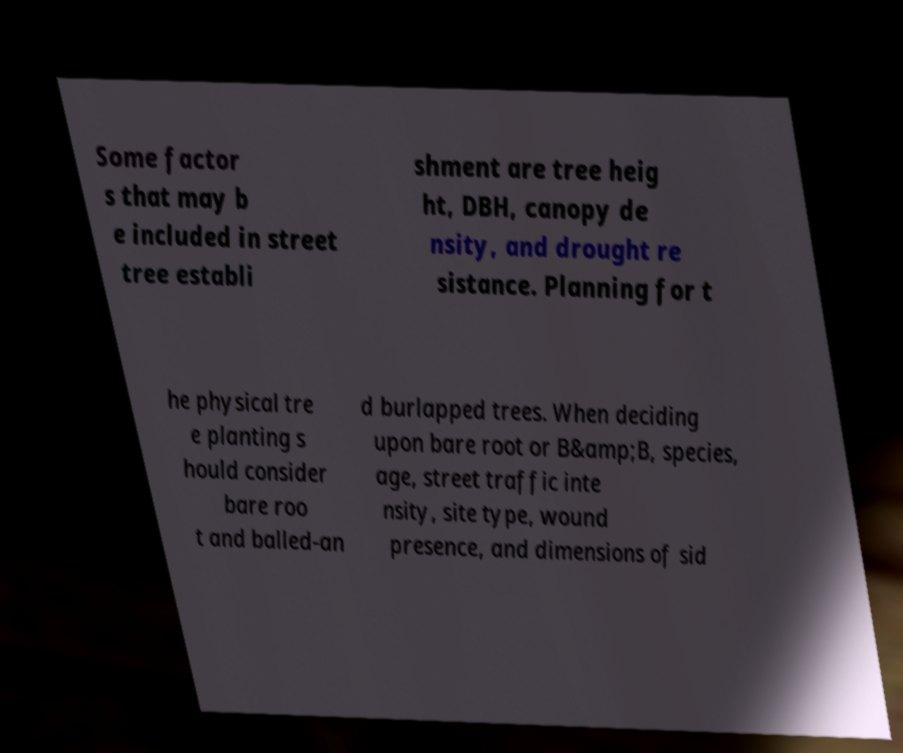Could you assist in decoding the text presented in this image and type it out clearly? Some factor s that may b e included in street tree establi shment are tree heig ht, DBH, canopy de nsity, and drought re sistance. Planning for t he physical tre e planting s hould consider bare roo t and balled-an d burlapped trees. When deciding upon bare root or B&amp;B, species, age, street traffic inte nsity, site type, wound presence, and dimensions of sid 